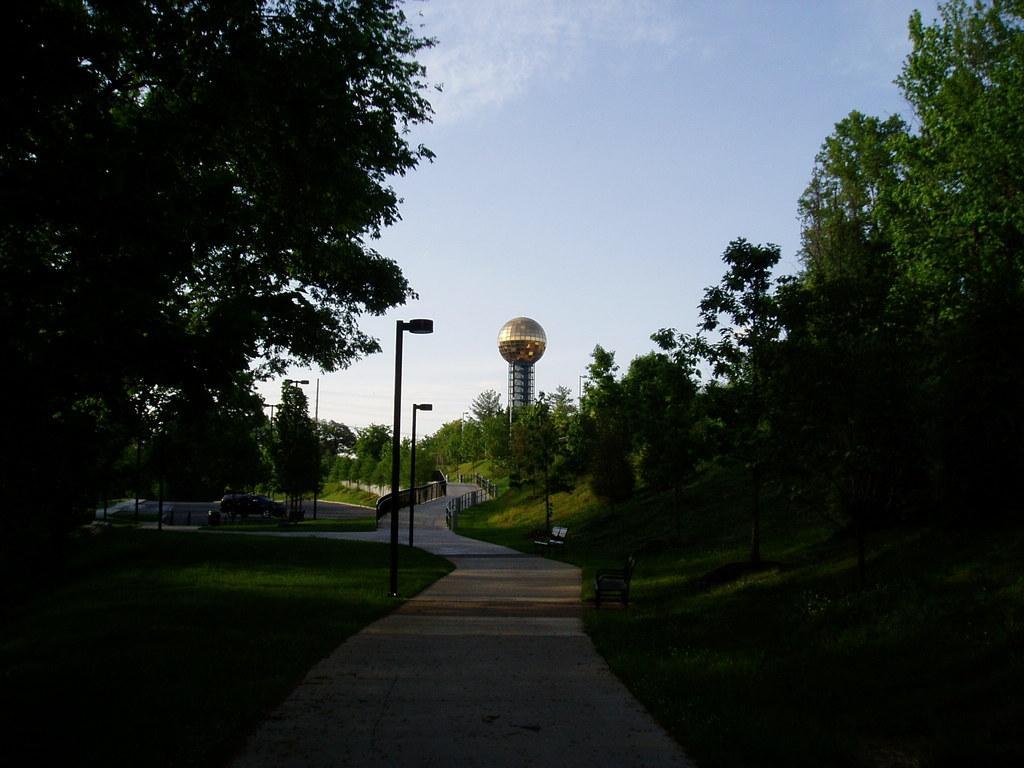How would you summarize this image in a sentence or two? In the middle of the image we can see some poles, trees, fencing and tower. At the top of the image there are some clouds in the sky. 